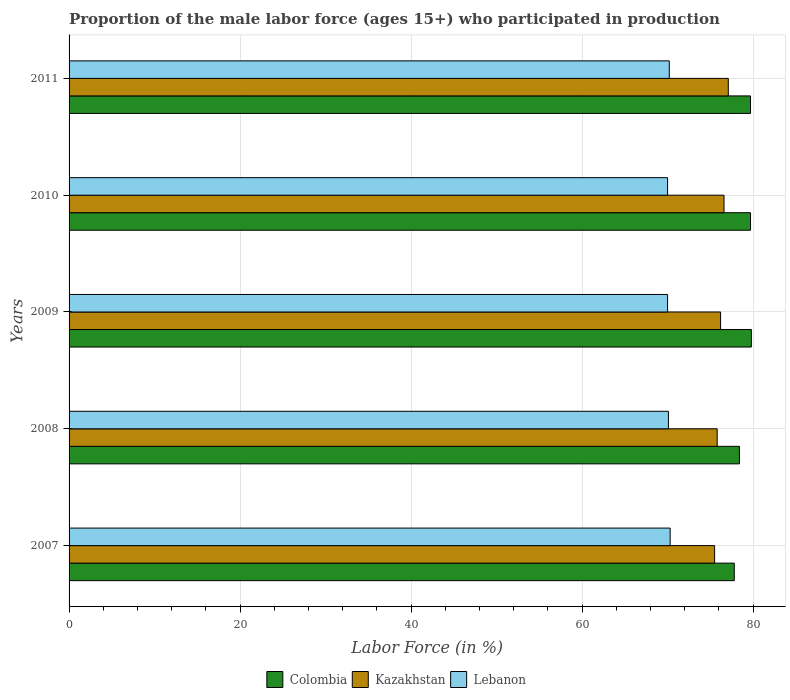How many different coloured bars are there?
Your response must be concise. 3. How many groups of bars are there?
Offer a terse response. 5. Are the number of bars per tick equal to the number of legend labels?
Your answer should be compact. Yes. Are the number of bars on each tick of the Y-axis equal?
Provide a succinct answer. Yes. How many bars are there on the 5th tick from the top?
Keep it short and to the point. 3. What is the proportion of the male labor force who participated in production in Kazakhstan in 2011?
Your response must be concise. 77.1. Across all years, what is the maximum proportion of the male labor force who participated in production in Colombia?
Keep it short and to the point. 79.8. Across all years, what is the minimum proportion of the male labor force who participated in production in Kazakhstan?
Make the answer very short. 75.5. In which year was the proportion of the male labor force who participated in production in Lebanon maximum?
Your answer should be very brief. 2007. In which year was the proportion of the male labor force who participated in production in Lebanon minimum?
Ensure brevity in your answer.  2009. What is the total proportion of the male labor force who participated in production in Lebanon in the graph?
Offer a terse response. 350.6. What is the difference between the proportion of the male labor force who participated in production in Colombia in 2008 and that in 2011?
Keep it short and to the point. -1.3. What is the average proportion of the male labor force who participated in production in Lebanon per year?
Keep it short and to the point. 70.12. In the year 2008, what is the difference between the proportion of the male labor force who participated in production in Kazakhstan and proportion of the male labor force who participated in production in Colombia?
Keep it short and to the point. -2.6. What is the ratio of the proportion of the male labor force who participated in production in Colombia in 2007 to that in 2008?
Your answer should be very brief. 0.99. Is the proportion of the male labor force who participated in production in Kazakhstan in 2009 less than that in 2010?
Your answer should be compact. Yes. Is the difference between the proportion of the male labor force who participated in production in Kazakhstan in 2008 and 2011 greater than the difference between the proportion of the male labor force who participated in production in Colombia in 2008 and 2011?
Ensure brevity in your answer.  Yes. What is the difference between the highest and the second highest proportion of the male labor force who participated in production in Lebanon?
Offer a very short reply. 0.1. What is the difference between the highest and the lowest proportion of the male labor force who participated in production in Lebanon?
Ensure brevity in your answer.  0.3. In how many years, is the proportion of the male labor force who participated in production in Lebanon greater than the average proportion of the male labor force who participated in production in Lebanon taken over all years?
Provide a short and direct response. 2. Is the sum of the proportion of the male labor force who participated in production in Colombia in 2007 and 2008 greater than the maximum proportion of the male labor force who participated in production in Kazakhstan across all years?
Your answer should be very brief. Yes. What does the 1st bar from the top in 2010 represents?
Give a very brief answer. Lebanon. What does the 3rd bar from the bottom in 2008 represents?
Provide a short and direct response. Lebanon. How many bars are there?
Make the answer very short. 15. Are all the bars in the graph horizontal?
Provide a succinct answer. Yes. Are the values on the major ticks of X-axis written in scientific E-notation?
Provide a succinct answer. No. Does the graph contain any zero values?
Keep it short and to the point. No. Where does the legend appear in the graph?
Your response must be concise. Bottom center. What is the title of the graph?
Ensure brevity in your answer.  Proportion of the male labor force (ages 15+) who participated in production. Does "Vietnam" appear as one of the legend labels in the graph?
Your answer should be compact. No. What is the label or title of the X-axis?
Ensure brevity in your answer.  Labor Force (in %). What is the label or title of the Y-axis?
Your answer should be very brief. Years. What is the Labor Force (in %) in Colombia in 2007?
Offer a terse response. 77.8. What is the Labor Force (in %) of Kazakhstan in 2007?
Your answer should be very brief. 75.5. What is the Labor Force (in %) of Lebanon in 2007?
Your answer should be very brief. 70.3. What is the Labor Force (in %) in Colombia in 2008?
Ensure brevity in your answer.  78.4. What is the Labor Force (in %) of Kazakhstan in 2008?
Keep it short and to the point. 75.8. What is the Labor Force (in %) of Lebanon in 2008?
Your answer should be compact. 70.1. What is the Labor Force (in %) of Colombia in 2009?
Provide a succinct answer. 79.8. What is the Labor Force (in %) in Kazakhstan in 2009?
Ensure brevity in your answer.  76.2. What is the Labor Force (in %) in Colombia in 2010?
Your response must be concise. 79.7. What is the Labor Force (in %) in Kazakhstan in 2010?
Your response must be concise. 76.6. What is the Labor Force (in %) in Lebanon in 2010?
Your answer should be very brief. 70. What is the Labor Force (in %) in Colombia in 2011?
Make the answer very short. 79.7. What is the Labor Force (in %) of Kazakhstan in 2011?
Offer a very short reply. 77.1. What is the Labor Force (in %) in Lebanon in 2011?
Make the answer very short. 70.2. Across all years, what is the maximum Labor Force (in %) in Colombia?
Provide a succinct answer. 79.8. Across all years, what is the maximum Labor Force (in %) in Kazakhstan?
Provide a succinct answer. 77.1. Across all years, what is the maximum Labor Force (in %) in Lebanon?
Give a very brief answer. 70.3. Across all years, what is the minimum Labor Force (in %) in Colombia?
Ensure brevity in your answer.  77.8. Across all years, what is the minimum Labor Force (in %) in Kazakhstan?
Provide a short and direct response. 75.5. Across all years, what is the minimum Labor Force (in %) in Lebanon?
Provide a short and direct response. 70. What is the total Labor Force (in %) of Colombia in the graph?
Make the answer very short. 395.4. What is the total Labor Force (in %) of Kazakhstan in the graph?
Ensure brevity in your answer.  381.2. What is the total Labor Force (in %) of Lebanon in the graph?
Offer a very short reply. 350.6. What is the difference between the Labor Force (in %) of Lebanon in 2007 and that in 2008?
Offer a very short reply. 0.2. What is the difference between the Labor Force (in %) of Colombia in 2007 and that in 2010?
Make the answer very short. -1.9. What is the difference between the Labor Force (in %) in Lebanon in 2007 and that in 2010?
Provide a short and direct response. 0.3. What is the difference between the Labor Force (in %) of Colombia in 2007 and that in 2011?
Your answer should be compact. -1.9. What is the difference between the Labor Force (in %) in Kazakhstan in 2007 and that in 2011?
Offer a terse response. -1.6. What is the difference between the Labor Force (in %) of Lebanon in 2008 and that in 2009?
Your answer should be very brief. 0.1. What is the difference between the Labor Force (in %) of Colombia in 2008 and that in 2010?
Provide a short and direct response. -1.3. What is the difference between the Labor Force (in %) in Lebanon in 2008 and that in 2010?
Make the answer very short. 0.1. What is the difference between the Labor Force (in %) in Kazakhstan in 2009 and that in 2010?
Offer a terse response. -0.4. What is the difference between the Labor Force (in %) in Lebanon in 2009 and that in 2010?
Your response must be concise. 0. What is the difference between the Labor Force (in %) of Colombia in 2009 and that in 2011?
Keep it short and to the point. 0.1. What is the difference between the Labor Force (in %) in Kazakhstan in 2009 and that in 2011?
Your answer should be compact. -0.9. What is the difference between the Labor Force (in %) of Lebanon in 2009 and that in 2011?
Your response must be concise. -0.2. What is the difference between the Labor Force (in %) of Colombia in 2007 and the Labor Force (in %) of Kazakhstan in 2008?
Give a very brief answer. 2. What is the difference between the Labor Force (in %) in Colombia in 2007 and the Labor Force (in %) in Lebanon in 2008?
Your response must be concise. 7.7. What is the difference between the Labor Force (in %) of Kazakhstan in 2007 and the Labor Force (in %) of Lebanon in 2008?
Make the answer very short. 5.4. What is the difference between the Labor Force (in %) of Colombia in 2007 and the Labor Force (in %) of Kazakhstan in 2009?
Your response must be concise. 1.6. What is the difference between the Labor Force (in %) of Colombia in 2007 and the Labor Force (in %) of Lebanon in 2009?
Provide a short and direct response. 7.8. What is the difference between the Labor Force (in %) in Kazakhstan in 2007 and the Labor Force (in %) in Lebanon in 2009?
Offer a very short reply. 5.5. What is the difference between the Labor Force (in %) of Kazakhstan in 2007 and the Labor Force (in %) of Lebanon in 2010?
Keep it short and to the point. 5.5. What is the difference between the Labor Force (in %) in Colombia in 2007 and the Labor Force (in %) in Lebanon in 2011?
Provide a short and direct response. 7.6. What is the difference between the Labor Force (in %) of Kazakhstan in 2007 and the Labor Force (in %) of Lebanon in 2011?
Your response must be concise. 5.3. What is the difference between the Labor Force (in %) of Colombia in 2008 and the Labor Force (in %) of Lebanon in 2009?
Your answer should be compact. 8.4. What is the difference between the Labor Force (in %) in Colombia in 2008 and the Labor Force (in %) in Lebanon in 2010?
Offer a very short reply. 8.4. What is the difference between the Labor Force (in %) of Kazakhstan in 2008 and the Labor Force (in %) of Lebanon in 2010?
Offer a terse response. 5.8. What is the average Labor Force (in %) of Colombia per year?
Provide a short and direct response. 79.08. What is the average Labor Force (in %) of Kazakhstan per year?
Ensure brevity in your answer.  76.24. What is the average Labor Force (in %) of Lebanon per year?
Give a very brief answer. 70.12. In the year 2007, what is the difference between the Labor Force (in %) in Kazakhstan and Labor Force (in %) in Lebanon?
Your answer should be very brief. 5.2. In the year 2008, what is the difference between the Labor Force (in %) in Kazakhstan and Labor Force (in %) in Lebanon?
Keep it short and to the point. 5.7. In the year 2009, what is the difference between the Labor Force (in %) of Colombia and Labor Force (in %) of Lebanon?
Give a very brief answer. 9.8. In the year 2011, what is the difference between the Labor Force (in %) of Colombia and Labor Force (in %) of Kazakhstan?
Your answer should be very brief. 2.6. In the year 2011, what is the difference between the Labor Force (in %) in Kazakhstan and Labor Force (in %) in Lebanon?
Offer a terse response. 6.9. What is the ratio of the Labor Force (in %) of Kazakhstan in 2007 to that in 2008?
Your response must be concise. 1. What is the ratio of the Labor Force (in %) in Colombia in 2007 to that in 2009?
Keep it short and to the point. 0.97. What is the ratio of the Labor Force (in %) of Kazakhstan in 2007 to that in 2009?
Give a very brief answer. 0.99. What is the ratio of the Labor Force (in %) of Lebanon in 2007 to that in 2009?
Provide a short and direct response. 1. What is the ratio of the Labor Force (in %) in Colombia in 2007 to that in 2010?
Make the answer very short. 0.98. What is the ratio of the Labor Force (in %) in Kazakhstan in 2007 to that in 2010?
Offer a very short reply. 0.99. What is the ratio of the Labor Force (in %) of Lebanon in 2007 to that in 2010?
Your response must be concise. 1. What is the ratio of the Labor Force (in %) of Colombia in 2007 to that in 2011?
Your answer should be very brief. 0.98. What is the ratio of the Labor Force (in %) of Kazakhstan in 2007 to that in 2011?
Keep it short and to the point. 0.98. What is the ratio of the Labor Force (in %) of Lebanon in 2007 to that in 2011?
Give a very brief answer. 1. What is the ratio of the Labor Force (in %) of Colombia in 2008 to that in 2009?
Your answer should be compact. 0.98. What is the ratio of the Labor Force (in %) in Kazakhstan in 2008 to that in 2009?
Provide a succinct answer. 0.99. What is the ratio of the Labor Force (in %) of Lebanon in 2008 to that in 2009?
Offer a very short reply. 1. What is the ratio of the Labor Force (in %) of Colombia in 2008 to that in 2010?
Keep it short and to the point. 0.98. What is the ratio of the Labor Force (in %) in Kazakhstan in 2008 to that in 2010?
Your answer should be very brief. 0.99. What is the ratio of the Labor Force (in %) in Lebanon in 2008 to that in 2010?
Give a very brief answer. 1. What is the ratio of the Labor Force (in %) in Colombia in 2008 to that in 2011?
Provide a succinct answer. 0.98. What is the ratio of the Labor Force (in %) in Kazakhstan in 2008 to that in 2011?
Your answer should be very brief. 0.98. What is the ratio of the Labor Force (in %) in Lebanon in 2008 to that in 2011?
Keep it short and to the point. 1. What is the ratio of the Labor Force (in %) in Lebanon in 2009 to that in 2010?
Your answer should be very brief. 1. What is the ratio of the Labor Force (in %) in Kazakhstan in 2009 to that in 2011?
Ensure brevity in your answer.  0.99. What is the difference between the highest and the second highest Labor Force (in %) in Colombia?
Give a very brief answer. 0.1. What is the difference between the highest and the second highest Labor Force (in %) in Kazakhstan?
Keep it short and to the point. 0.5. What is the difference between the highest and the lowest Labor Force (in %) in Colombia?
Make the answer very short. 2. What is the difference between the highest and the lowest Labor Force (in %) in Kazakhstan?
Provide a short and direct response. 1.6. 